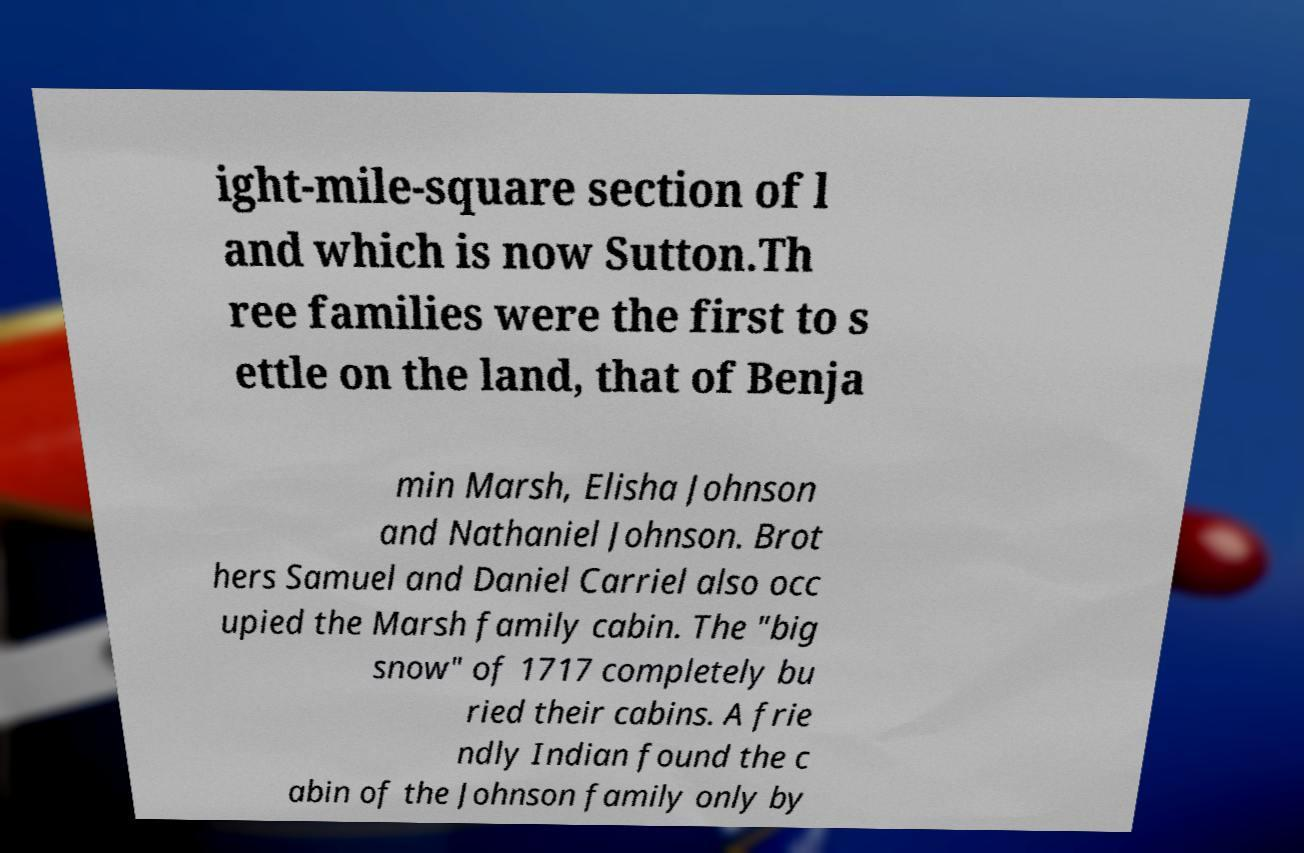What messages or text are displayed in this image? I need them in a readable, typed format. ight-mile-square section of l and which is now Sutton.Th ree families were the first to s ettle on the land, that of Benja min Marsh, Elisha Johnson and Nathaniel Johnson. Brot hers Samuel and Daniel Carriel also occ upied the Marsh family cabin. The "big snow" of 1717 completely bu ried their cabins. A frie ndly Indian found the c abin of the Johnson family only by 